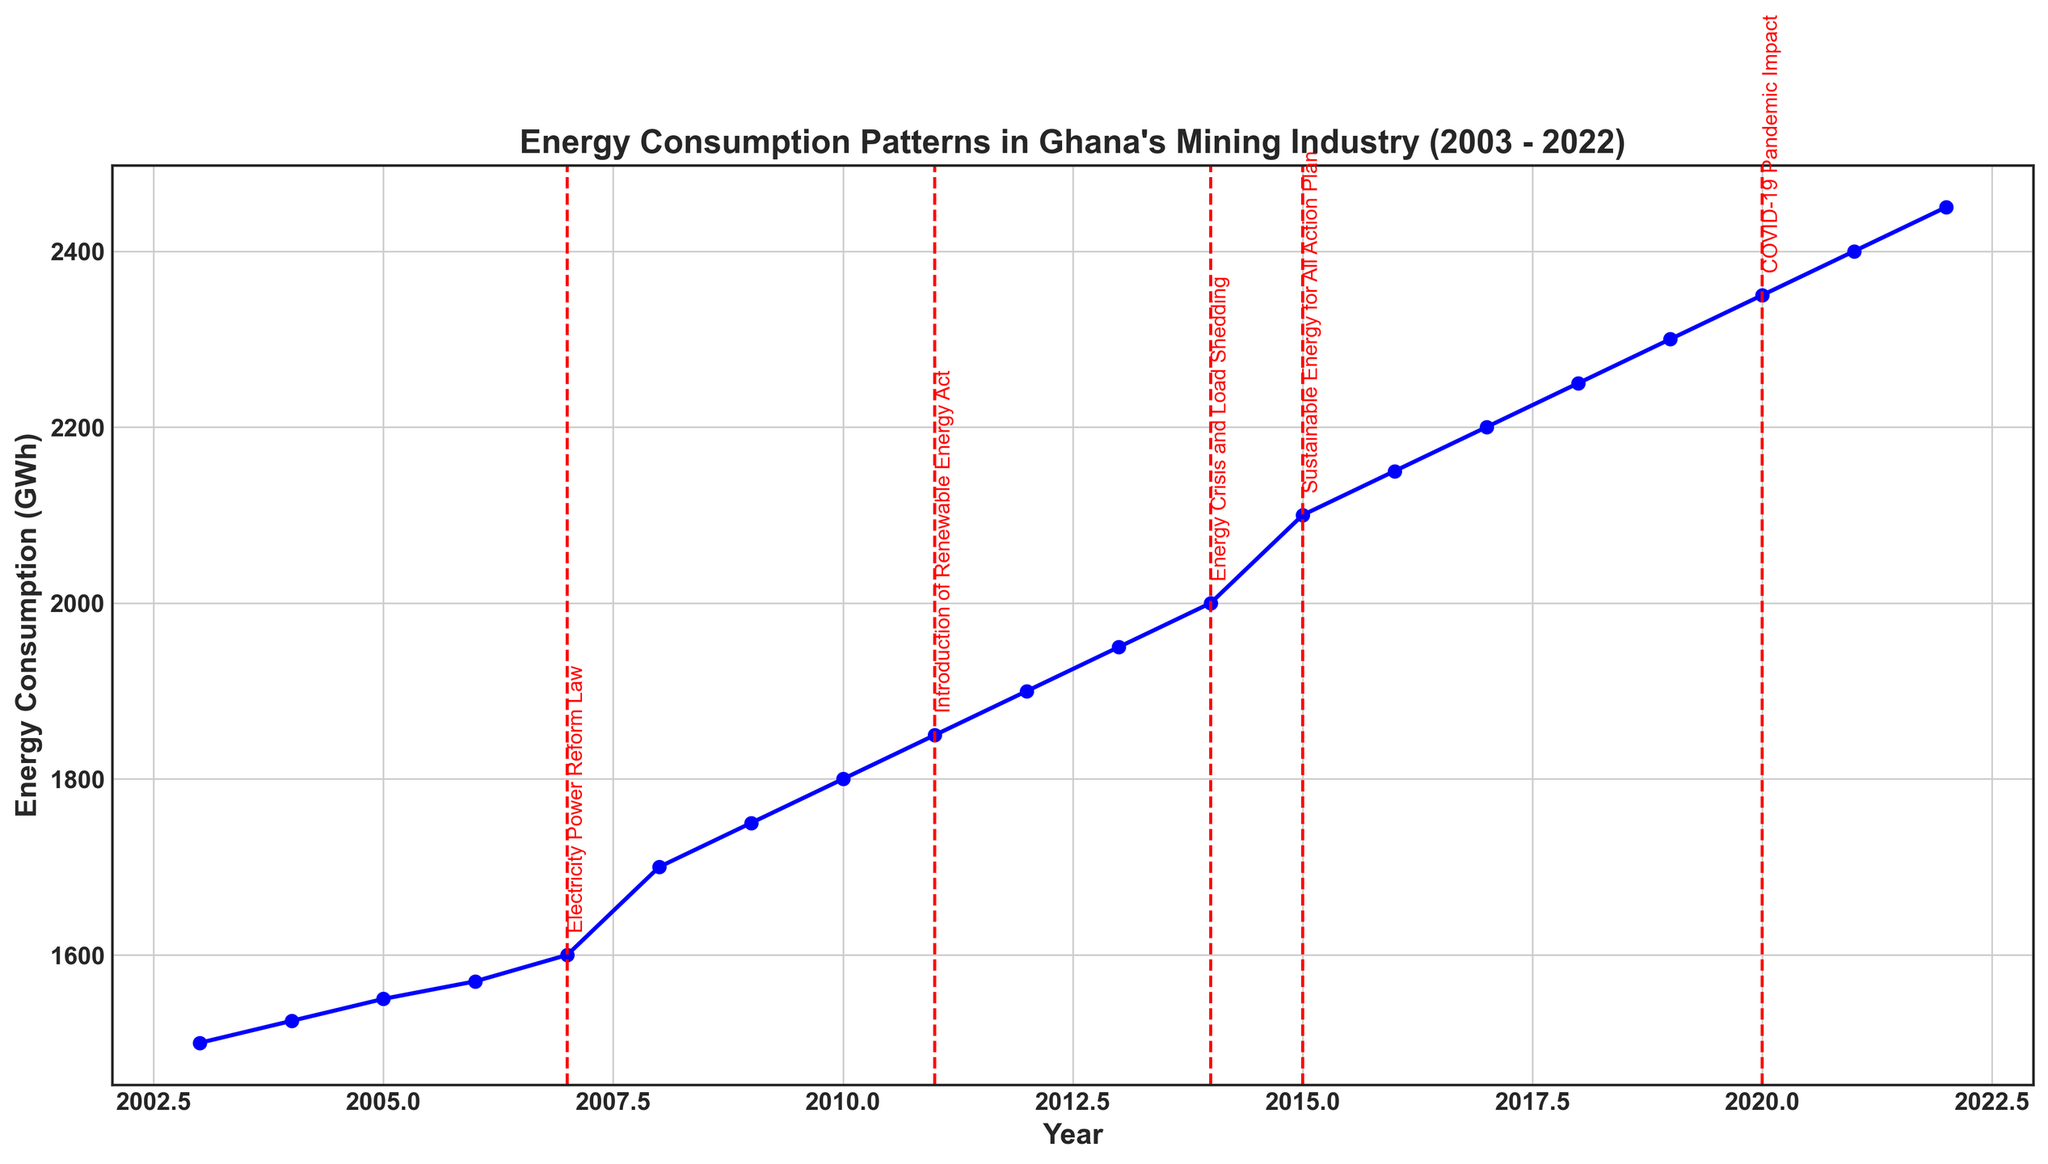What policy change occurred in 2007 and how did energy consumption patterns change before and after this year? The Electricity Power Reform Law was enacted in 2007. Before 2007, the energy consumption increased gradually from 1500 GWh in 2003 to 1600 GWh in 2007. After 2007, consumption continued to rise, reaching 1700 GWh in 2008. This indicates a continued trend of increasing energy consumption post-policy change.
Answer: Electricity Power Reform Law; consumption increased steadily both before and after the policy change How did the energy consumption change during the years of significant policy impacts in 2011 and 2014? In 2011, the Renewable Energy Act was introduced, increasing energy consumption from 1800 GWh in 2010 to 1850 GWh in 2011. In 2014, during the Energy Crisis and Load Shedding period, consumption increased from 1950 GWh in 2013 to 2000 GWh in 2014.
Answer: Increased during both years of policy impacts What is the average energy consumption between 2003 and 2022? Sum the energy consumption from 2003 to 2022 and divide by the number of years: (1500+1525+1550+1570+1600+1700+1750+1800+1850+1900+1950+2000+2100+2150+2200+2250+2300+2350+2400+2450)/20 = 1957.5 GWh.
Answer: 1957.5 GWh Did the energy consumption increase more between 2010-2011 or 2009-2010? From 2009 to 2010, the energy consumption increased from 1750 GWh to 1800 GWh, a change of 50 GWh. From 2010 to 2011, it increased from 1800 GWh to 1850 GWh, a change of 50 GWh. Therefore, the increases are equal.
Answer: Equal (50 GWh) Which year saw the highest increase in energy consumption compared to the previous year? From 2014 to 2015, energy consumption increased from 2000 GWh to 2100 GWh, an increase of 100 GWh, which is higher than any other yearly increase.
Answer: 2015 Is there any visible trend in energy consumption from 2003 to 2022? From 2003 to 2022, energy consumption shows an overall increasing trend. Although there are variations each year, the general trend is an upward growth in energy utilization.
Answer: Increasing trend What was the energy consumption in 2020 and what significant event impacted that year? The energy consumption in 2020 was 2350 GWh, and it was impacted by the COVID-19 Pandemic.
Answer: 2350 GWh; COVID-19 Pandemic Between which two consecutive years do we observe the smallest increase in energy consumption? The smallest increase is observed between 2006 and 2007, where the energy consumption increased from 1570 GWh to 1600 GWh, an increase of 30 GWh.
Answer: 2006 and 2007 How did the energy consumption change during the introduction of the Sustainable Energy for All Action Plan in 2015? In 2015, energy consumption increased from 2000 GWh in 2014 to 2100 GWh.
Answer: Increased by 100 GWh How do the years 2019 and 2020 compare in terms of energy consumption? The energy consumption in 2019 was 2300 GWh, while in 2020 it was 2350 GWh. Therefore, 2020 had a higher energy consumption than 2019 by 50 GWh.
Answer: 2020 had higher consumption 